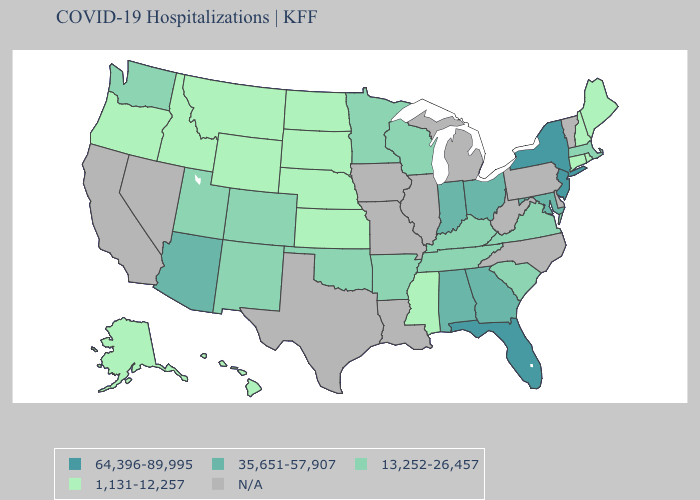Does the map have missing data?
Quick response, please. Yes. Does South Dakota have the highest value in the USA?
Answer briefly. No. What is the highest value in states that border Maine?
Write a very short answer. 1,131-12,257. Does Rhode Island have the lowest value in the USA?
Write a very short answer. Yes. Does New York have the highest value in the Northeast?
Quick response, please. Yes. What is the lowest value in the USA?
Give a very brief answer. 1,131-12,257. Name the states that have a value in the range N/A?
Be succinct. California, Delaware, Illinois, Iowa, Louisiana, Michigan, Missouri, Nevada, North Carolina, Pennsylvania, Texas, Vermont, West Virginia. What is the lowest value in the MidWest?
Answer briefly. 1,131-12,257. What is the value of Alaska?
Be succinct. 1,131-12,257. Among the states that border Montana , which have the lowest value?
Give a very brief answer. Idaho, North Dakota, South Dakota, Wyoming. Is the legend a continuous bar?
Give a very brief answer. No. Name the states that have a value in the range 13,252-26,457?
Quick response, please. Arkansas, Colorado, Kentucky, Massachusetts, Minnesota, New Mexico, Oklahoma, South Carolina, Tennessee, Utah, Virginia, Washington, Wisconsin. Name the states that have a value in the range N/A?
Keep it brief. California, Delaware, Illinois, Iowa, Louisiana, Michigan, Missouri, Nevada, North Carolina, Pennsylvania, Texas, Vermont, West Virginia. 